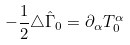Convert formula to latex. <formula><loc_0><loc_0><loc_500><loc_500>- \frac { 1 } { 2 } \triangle \hat { \Gamma } _ { 0 } = \partial _ { \alpha } T ^ { \alpha } _ { 0 }</formula> 